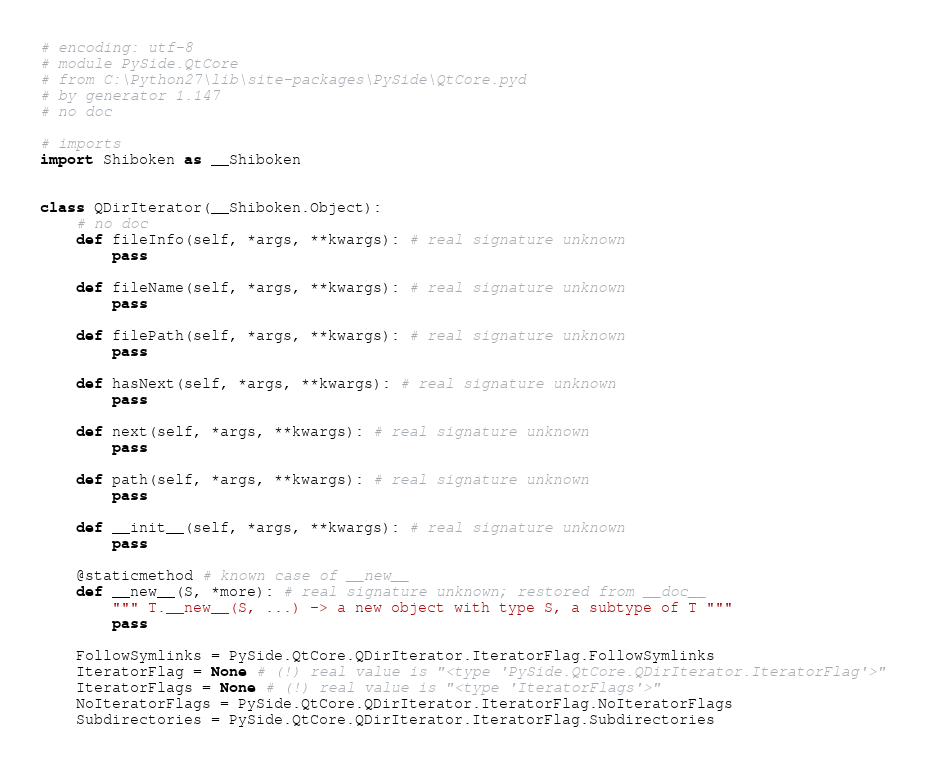<code> <loc_0><loc_0><loc_500><loc_500><_Python_># encoding: utf-8
# module PySide.QtCore
# from C:\Python27\lib\site-packages\PySide\QtCore.pyd
# by generator 1.147
# no doc

# imports
import Shiboken as __Shiboken


class QDirIterator(__Shiboken.Object):
    # no doc
    def fileInfo(self, *args, **kwargs): # real signature unknown
        pass

    def fileName(self, *args, **kwargs): # real signature unknown
        pass

    def filePath(self, *args, **kwargs): # real signature unknown
        pass

    def hasNext(self, *args, **kwargs): # real signature unknown
        pass

    def next(self, *args, **kwargs): # real signature unknown
        pass

    def path(self, *args, **kwargs): # real signature unknown
        pass

    def __init__(self, *args, **kwargs): # real signature unknown
        pass

    @staticmethod # known case of __new__
    def __new__(S, *more): # real signature unknown; restored from __doc__
        """ T.__new__(S, ...) -> a new object with type S, a subtype of T """
        pass

    FollowSymlinks = PySide.QtCore.QDirIterator.IteratorFlag.FollowSymlinks
    IteratorFlag = None # (!) real value is "<type 'PySide.QtCore.QDirIterator.IteratorFlag'>"
    IteratorFlags = None # (!) real value is "<type 'IteratorFlags'>"
    NoIteratorFlags = PySide.QtCore.QDirIterator.IteratorFlag.NoIteratorFlags
    Subdirectories = PySide.QtCore.QDirIterator.IteratorFlag.Subdirectories


</code> 